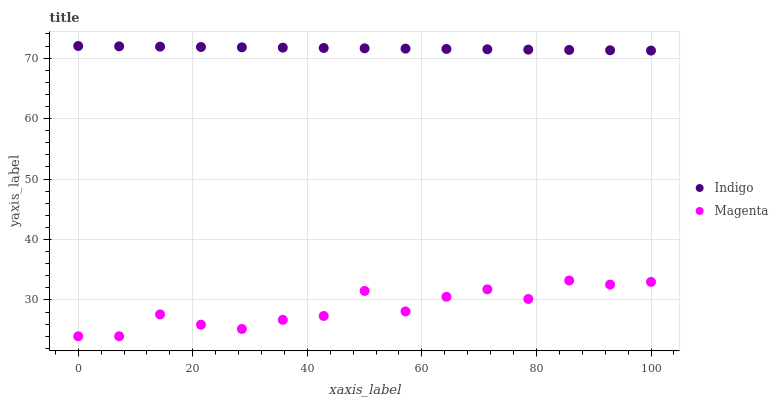Does Magenta have the minimum area under the curve?
Answer yes or no. Yes. Does Indigo have the maximum area under the curve?
Answer yes or no. Yes. Does Indigo have the minimum area under the curve?
Answer yes or no. No. Is Indigo the smoothest?
Answer yes or no. Yes. Is Magenta the roughest?
Answer yes or no. Yes. Is Indigo the roughest?
Answer yes or no. No. Does Magenta have the lowest value?
Answer yes or no. Yes. Does Indigo have the lowest value?
Answer yes or no. No. Does Indigo have the highest value?
Answer yes or no. Yes. Is Magenta less than Indigo?
Answer yes or no. Yes. Is Indigo greater than Magenta?
Answer yes or no. Yes. Does Magenta intersect Indigo?
Answer yes or no. No. 